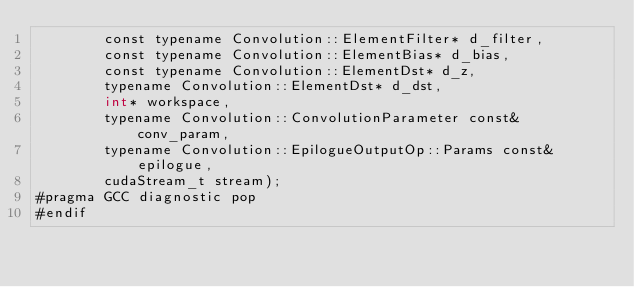Convert code to text. <code><loc_0><loc_0><loc_500><loc_500><_Cuda_>        const typename Convolution::ElementFilter* d_filter, 
        const typename Convolution::ElementBias* d_bias, 
        const typename Convolution::ElementDst* d_z, 
        typename Convolution::ElementDst* d_dst, 
        int* workspace, 
        typename Convolution::ConvolutionParameter const& conv_param, 
        typename Convolution::EpilogueOutputOp::Params const& epilogue, 
        cudaStream_t stream);
#pragma GCC diagnostic pop
#endif
</code> 